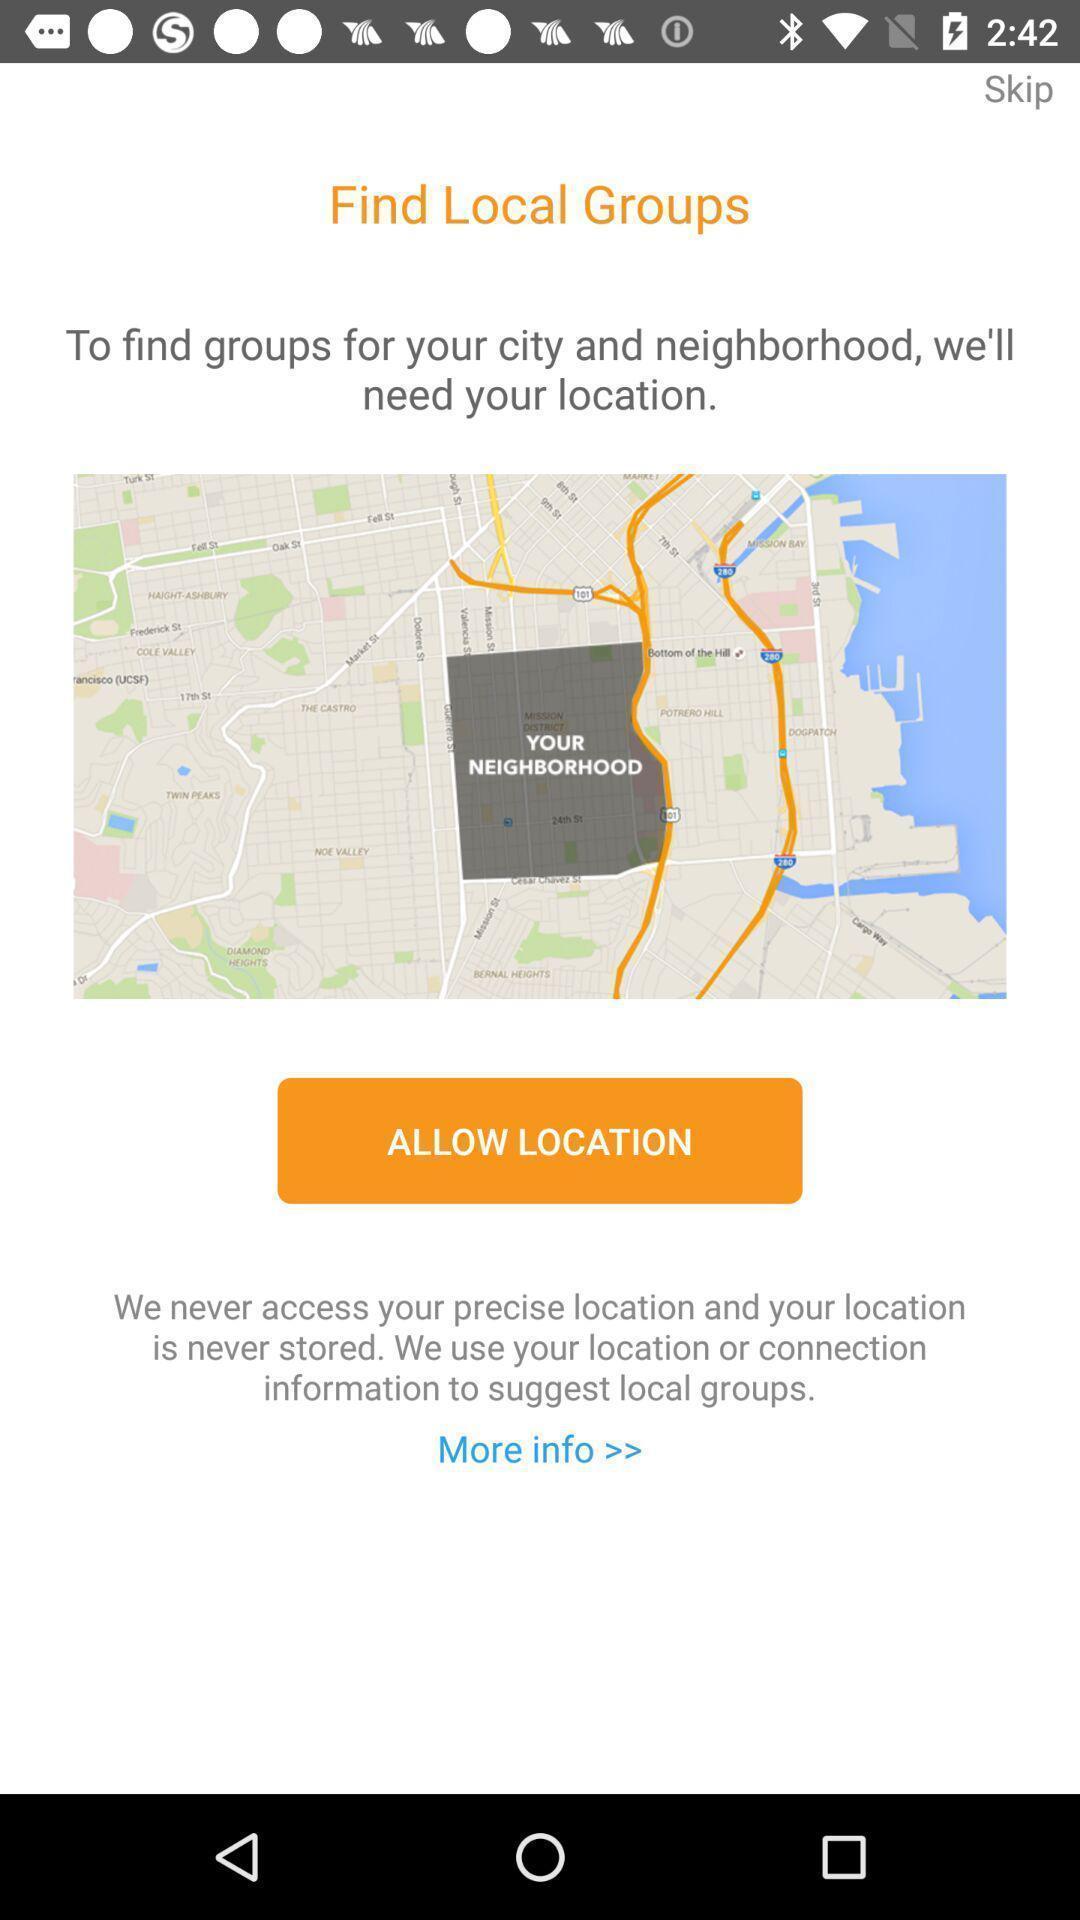Provide a detailed account of this screenshot. Screen shows to find local groups. 